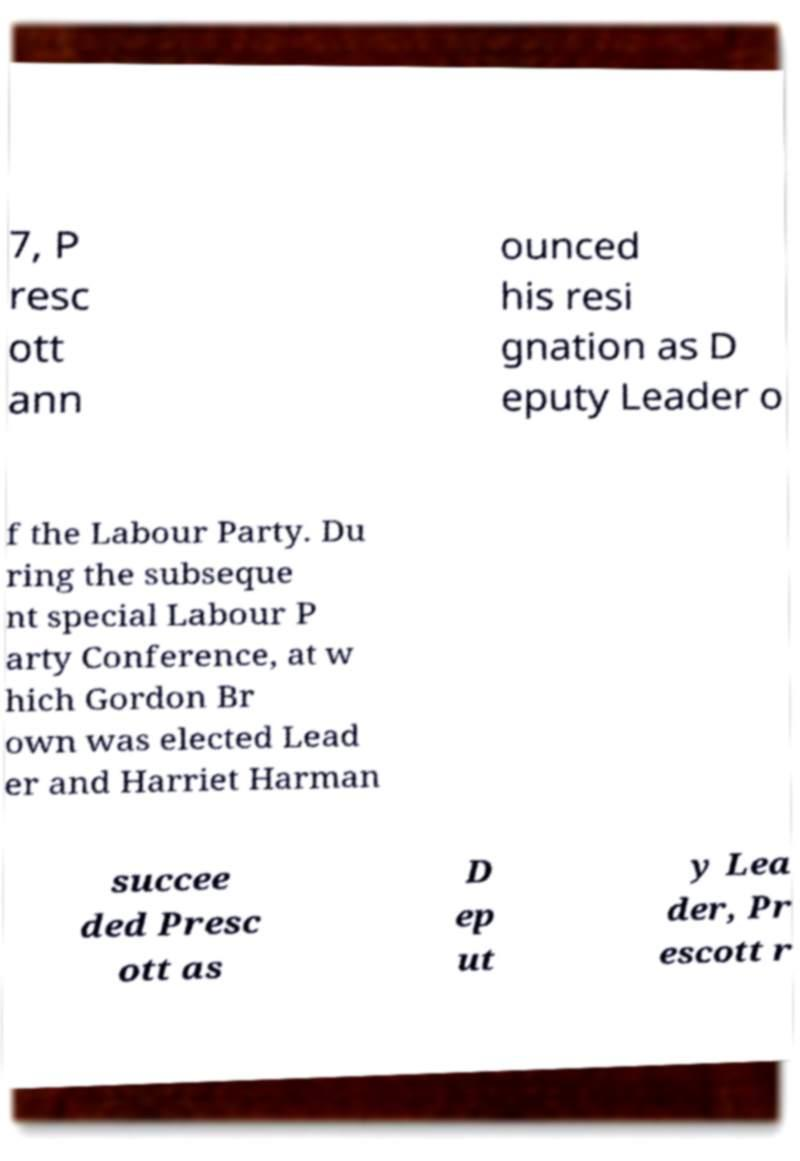Please read and relay the text visible in this image. What does it say? 7, P resc ott ann ounced his resi gnation as D eputy Leader o f the Labour Party. Du ring the subseque nt special Labour P arty Conference, at w hich Gordon Br own was elected Lead er and Harriet Harman succee ded Presc ott as D ep ut y Lea der, Pr escott r 